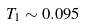<formula> <loc_0><loc_0><loc_500><loc_500>T _ { 1 } \sim 0 . 0 9 5</formula> 